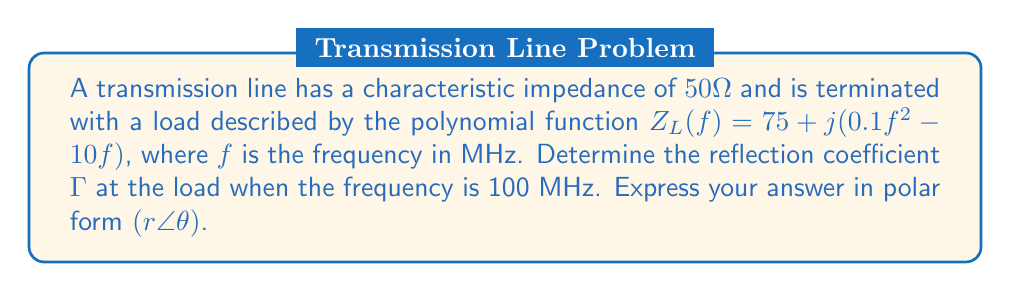Teach me how to tackle this problem. To solve this problem, we'll follow these steps:

1) First, we need to calculate the load impedance $Z_L$ at 100 MHz:
   
   $Z_L(100) = 75 + j(0.1(100)^2 - 10(100))$
   $= 75 + j(1000 - 1000)$
   $= 75 + j0 = 75\Omega$

2) The reflection coefficient $\Gamma$ is given by the formula:

   $$\Gamma = \frac{Z_L - Z_0}{Z_L + Z_0}$$

   where $Z_L$ is the load impedance and $Z_0$ is the characteristic impedance.

3) Substituting the values:

   $$\Gamma = \frac{75 - 50}{75 + 50} = \frac{25}{125} = 0.2$$

4) To convert to polar form, we need the magnitude and angle:
   
   Magnitude: $r = |\Gamma| = 0.2$
   
   Angle: $\theta = \arg(\Gamma) = 0°$ (since $\Gamma$ is real and positive)

5) Therefore, in polar form: $\Gamma = 0.2\angle0°$
Answer: $0.2\angle0°$ 